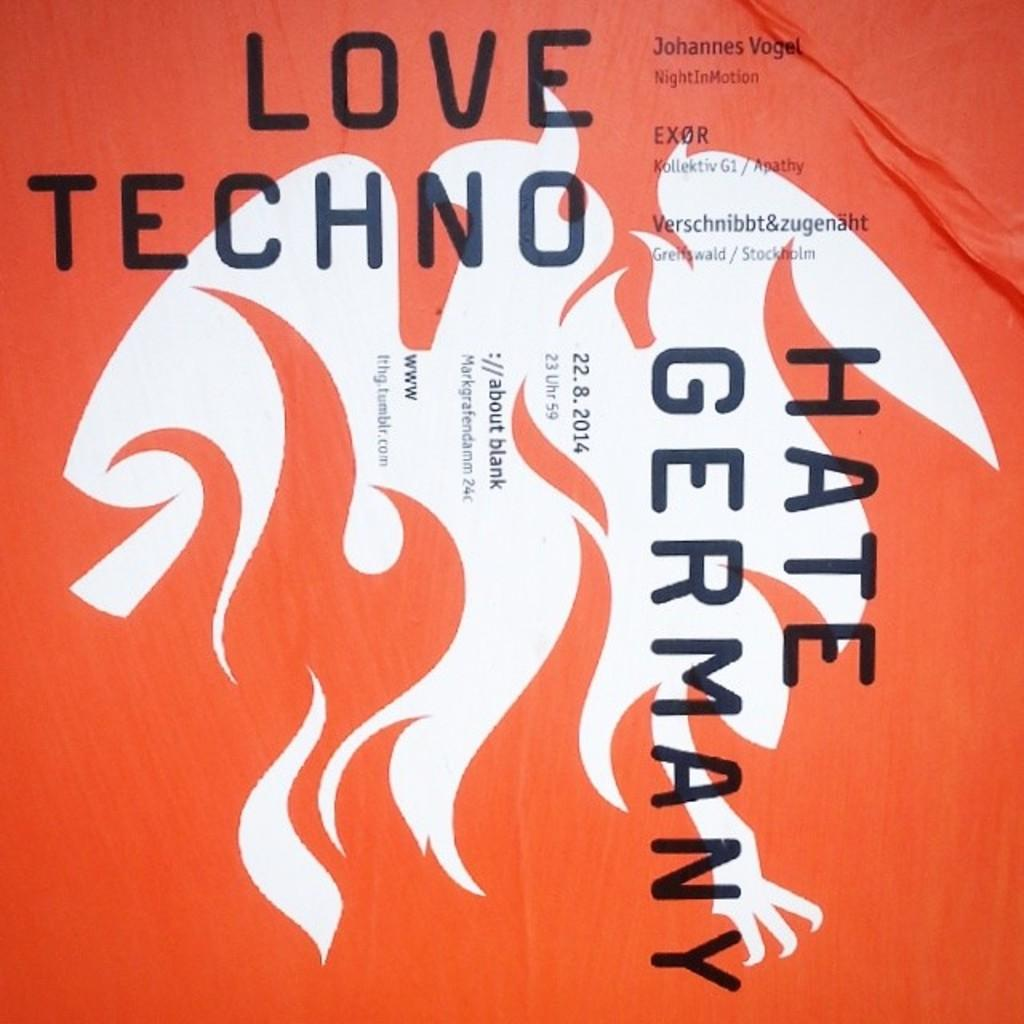Provide a one-sentence caption for the provided image. A book with an orange cover called Hate Germany. 